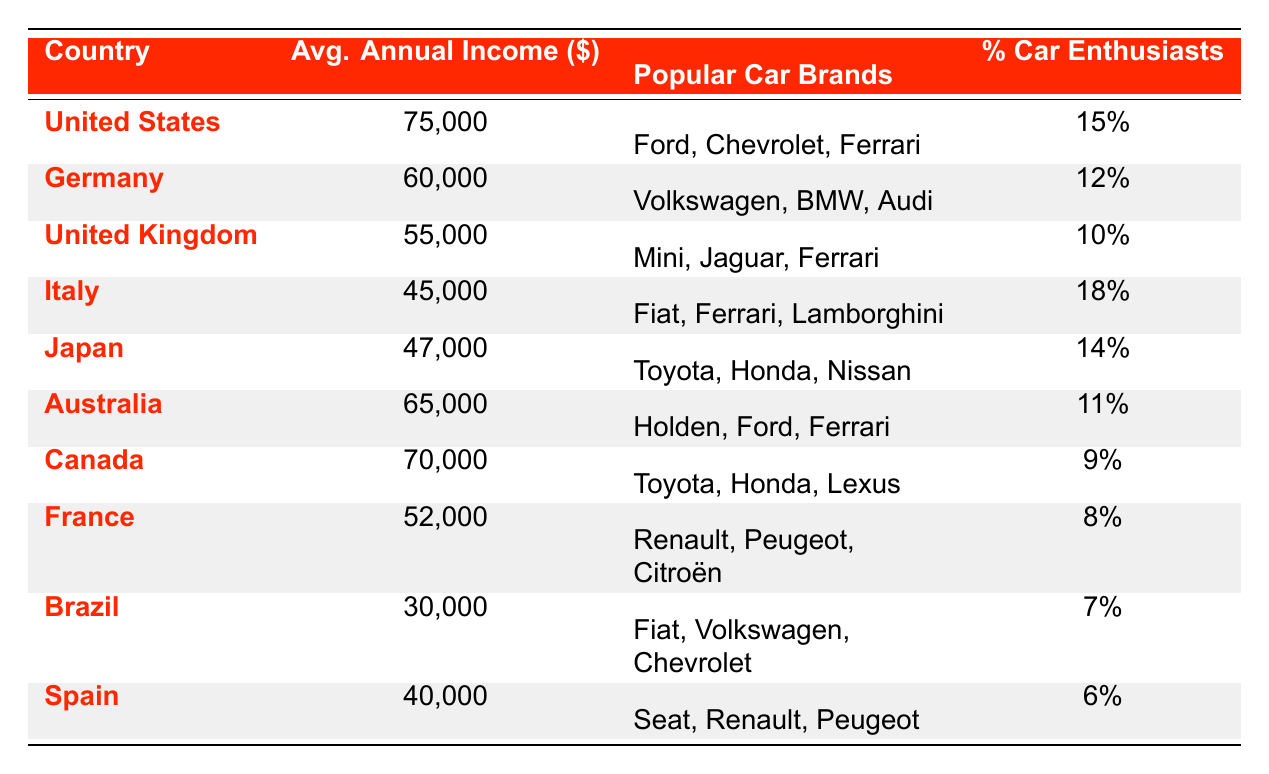What is the average annual income of car enthusiasts in the United States? From the table, the section for the United States reads that the average annual income is 75,000.
Answer: 75,000 Which country has the highest average annual income for car enthusiasts? By comparing the average annual income values, the United States (75,000) has the highest income, followed by Australia (65,000) and Canada (70,000).
Answer: United States What are the popular car brands in Italy? According to the table, Italy has popular car brands listed as Fiat, Ferrari, and Lamborghini.
Answer: Fiat, Ferrari, Lamborghini Is the percentage of car enthusiasts in Brazil higher than in Spain? The table shows that Brazil has 7% car enthusiasts, and Spain has 6%. Since 7% is higher than 6%, the statement is true.
Answer: Yes What is the difference in average annual income between Germany and the United Kingdom? The average annual income in Germany is 60,000 and in the United Kingdom is 55,000. The difference is calculated as 60,000 - 55,000 = 5,000.
Answer: 5,000 If you add the average annual incomes of Japan and France, what total do you get? Japan's average annual income is 47,000 and France's is 52,000. Adding these gives 47,000 + 52,000 = 99,000.
Answer: 99,000 Does Canada have a higher average annual income than both Japan and Italy? Canada has an average annual income of 70,000, Japan has 47,000, and Italy has 45,000. Since 70,000 is higher than both 47,000 and 45,000, the answer is yes.
Answer: Yes Which country has the lowest average annual income among car enthusiasts? By reviewing the table, Brazil has the average annual income of 30,000, which is the lowest compared to other countries listed.
Answer: Brazil How many countries have an average annual income of 55,000 or more? The countries with an average annual income of 55,000 or more are United States, Germany, United Kingdom, Australia, and Canada. That gives a total of 5 countries.
Answer: 5 